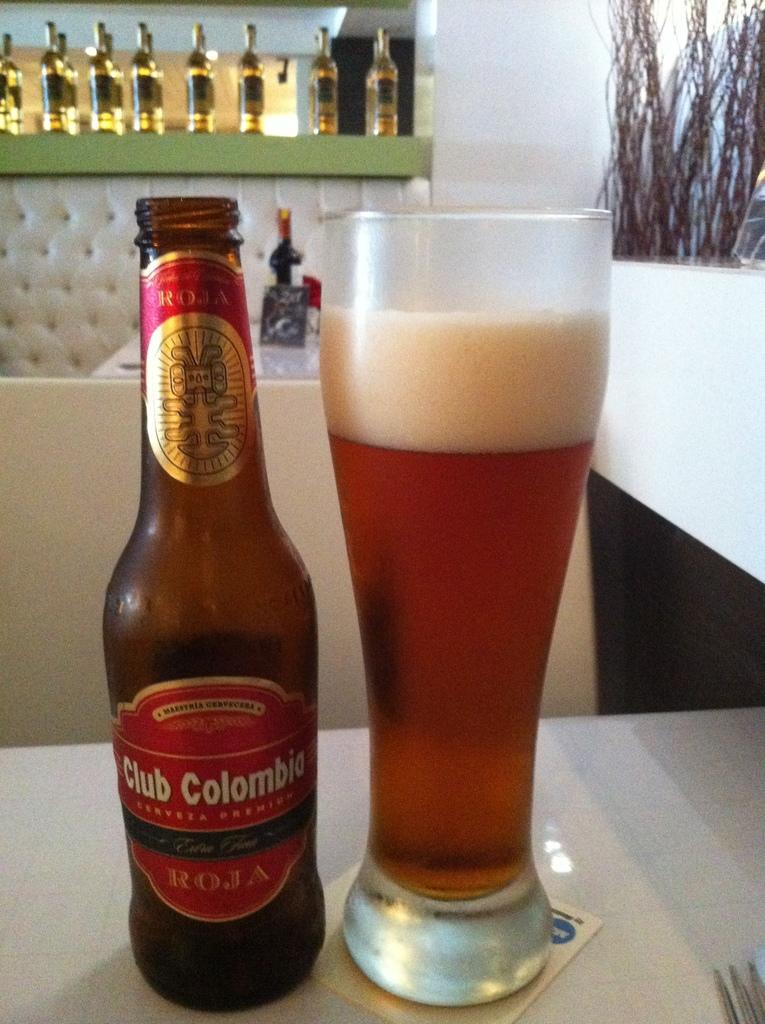<image>
Summarize the visual content of the image. A bottle of Club Colombia beer next to a glass of beer. 